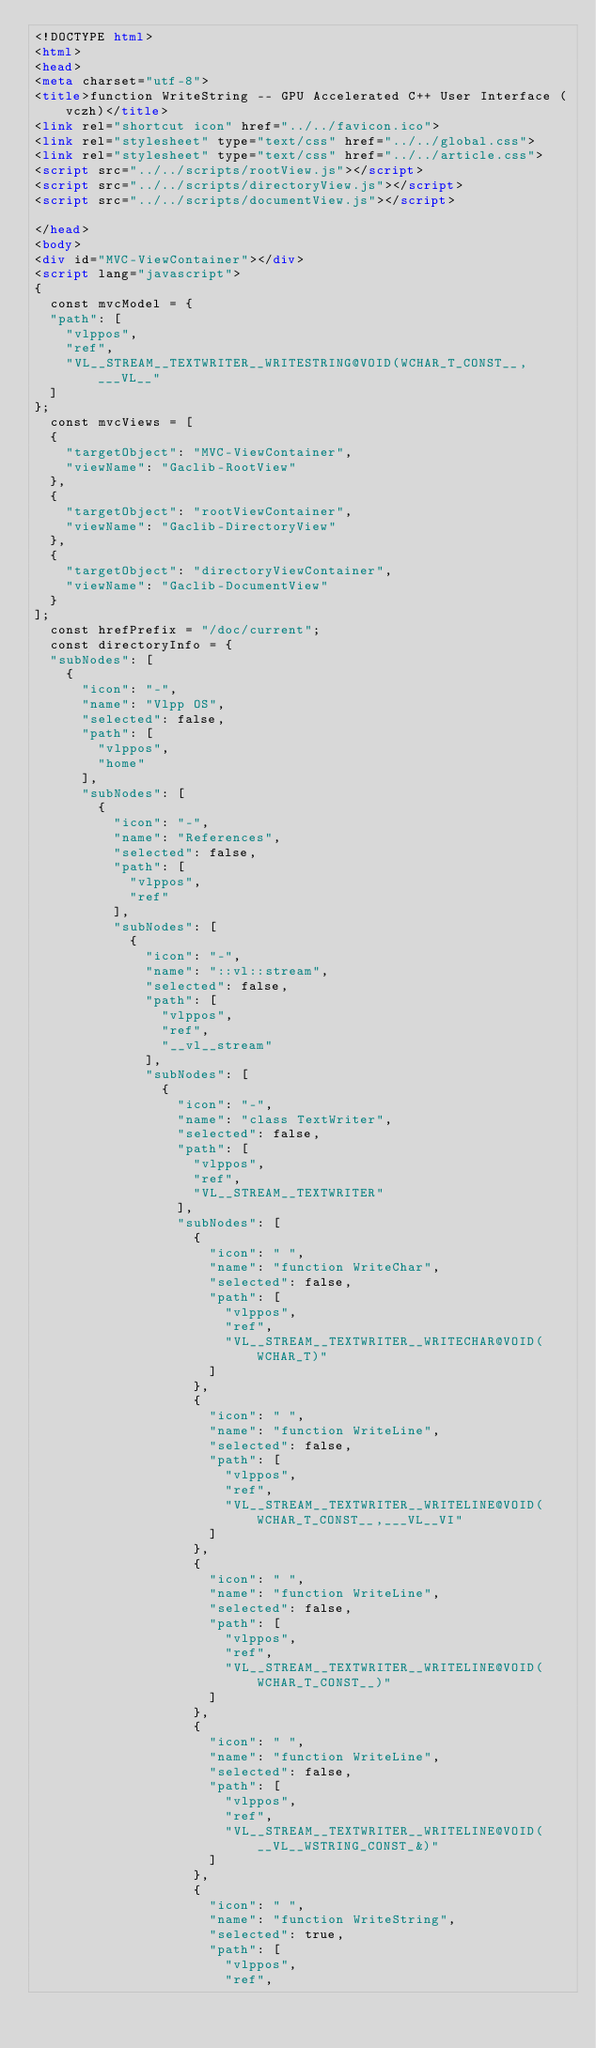Convert code to text. <code><loc_0><loc_0><loc_500><loc_500><_HTML_><!DOCTYPE html>
<html>
<head>
<meta charset="utf-8">
<title>function WriteString -- GPU Accelerated C++ User Interface (vczh)</title>
<link rel="shortcut icon" href="../../favicon.ico">
<link rel="stylesheet" type="text/css" href="../../global.css">
<link rel="stylesheet" type="text/css" href="../../article.css">
<script src="../../scripts/rootView.js"></script>
<script src="../../scripts/directoryView.js"></script>
<script src="../../scripts/documentView.js"></script>

</head>
<body>
<div id="MVC-ViewContainer"></div>
<script lang="javascript">
{
  const mvcModel = {
  "path": [
    "vlppos",
    "ref",
    "VL__STREAM__TEXTWRITER__WRITESTRING@VOID(WCHAR_T_CONST__,___VL__"
  ]
};
  const mvcViews = [
  {
    "targetObject": "MVC-ViewContainer",
    "viewName": "Gaclib-RootView"
  },
  {
    "targetObject": "rootViewContainer",
    "viewName": "Gaclib-DirectoryView"
  },
  {
    "targetObject": "directoryViewContainer",
    "viewName": "Gaclib-DocumentView"
  }
];
  const hrefPrefix = "/doc/current";
  const directoryInfo = {
  "subNodes": [
    {
      "icon": "-",
      "name": "Vlpp OS",
      "selected": false,
      "path": [
        "vlppos",
        "home"
      ],
      "subNodes": [
        {
          "icon": "-",
          "name": "References",
          "selected": false,
          "path": [
            "vlppos",
            "ref"
          ],
          "subNodes": [
            {
              "icon": "-",
              "name": "::vl::stream",
              "selected": false,
              "path": [
                "vlppos",
                "ref",
                "__vl__stream"
              ],
              "subNodes": [
                {
                  "icon": "-",
                  "name": "class TextWriter",
                  "selected": false,
                  "path": [
                    "vlppos",
                    "ref",
                    "VL__STREAM__TEXTWRITER"
                  ],
                  "subNodes": [
                    {
                      "icon": " ",
                      "name": "function WriteChar",
                      "selected": false,
                      "path": [
                        "vlppos",
                        "ref",
                        "VL__STREAM__TEXTWRITER__WRITECHAR@VOID(WCHAR_T)"
                      ]
                    },
                    {
                      "icon": " ",
                      "name": "function WriteLine",
                      "selected": false,
                      "path": [
                        "vlppos",
                        "ref",
                        "VL__STREAM__TEXTWRITER__WRITELINE@VOID(WCHAR_T_CONST__,___VL__VI"
                      ]
                    },
                    {
                      "icon": " ",
                      "name": "function WriteLine",
                      "selected": false,
                      "path": [
                        "vlppos",
                        "ref",
                        "VL__STREAM__TEXTWRITER__WRITELINE@VOID(WCHAR_T_CONST__)"
                      ]
                    },
                    {
                      "icon": " ",
                      "name": "function WriteLine",
                      "selected": false,
                      "path": [
                        "vlppos",
                        "ref",
                        "VL__STREAM__TEXTWRITER__WRITELINE@VOID(__VL__WSTRING_CONST_&)"
                      ]
                    },
                    {
                      "icon": " ",
                      "name": "function WriteString",
                      "selected": true,
                      "path": [
                        "vlppos",
                        "ref",</code> 